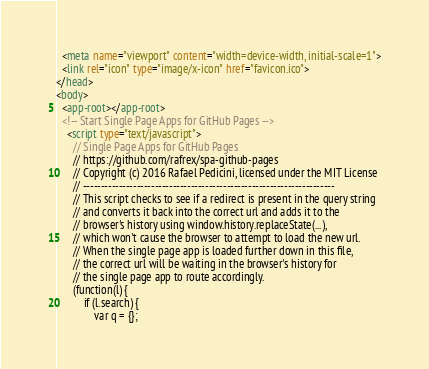Convert code to text. <code><loc_0><loc_0><loc_500><loc_500><_HTML_>  <meta name="viewport" content="width=device-width, initial-scale=1">
  <link rel="icon" type="image/x-icon" href="favicon.ico">
</head>
<body>
  <app-root></app-root>
  <!-- Start Single Page Apps for GitHub Pages -->
    <script type="text/javascript">
      // Single Page Apps for GitHub Pages
      // https://github.com/rafrex/spa-github-pages
      // Copyright (c) 2016 Rafael Pedicini, licensed under the MIT License
      // ----------------------------------------------------------------------
      // This script checks to see if a redirect is present in the query string
      // and converts it back into the correct url and adds it to the
      // browser's history using window.history.replaceState(...),
      // which won't cause the browser to attempt to load the new url.
      // When the single page app is loaded further down in this file,
      // the correct url will be waiting in the browser's history for
      // the single page app to route accordingly.
      (function(l) {
          if (l.search) {
              var q = {};</code> 